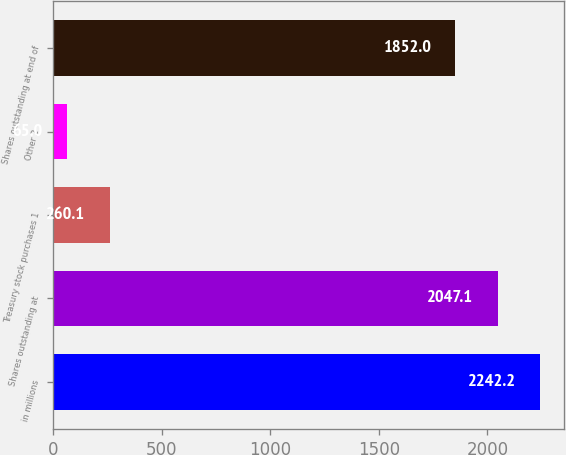Convert chart. <chart><loc_0><loc_0><loc_500><loc_500><bar_chart><fcel>in millions<fcel>Shares outstanding at<fcel>Treasury stock purchases 1<fcel>Other 2<fcel>Shares outstanding at end of<nl><fcel>2242.2<fcel>2047.1<fcel>260.1<fcel>65<fcel>1852<nl></chart> 